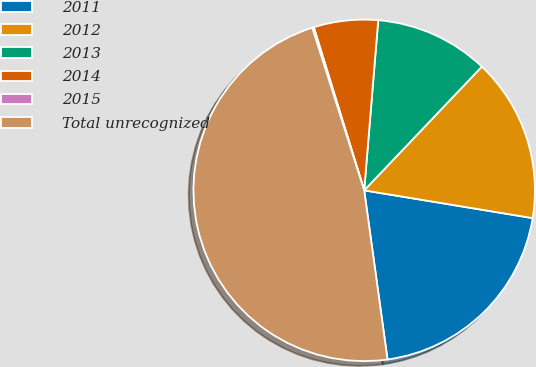Convert chart to OTSL. <chart><loc_0><loc_0><loc_500><loc_500><pie_chart><fcel>2011<fcel>2012<fcel>2013<fcel>2014<fcel>2015<fcel>Total unrecognized<nl><fcel>20.22%<fcel>15.5%<fcel>10.79%<fcel>6.08%<fcel>0.15%<fcel>47.26%<nl></chart> 